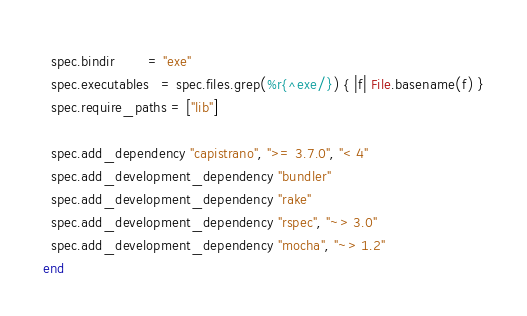<code> <loc_0><loc_0><loc_500><loc_500><_Ruby_>  spec.bindir        = "exe"
  spec.executables   = spec.files.grep(%r{^exe/}) { |f| File.basename(f) }
  spec.require_paths = ["lib"]

  spec.add_dependency "capistrano", ">= 3.7.0", "< 4"
  spec.add_development_dependency "bundler"
  spec.add_development_dependency "rake"
  spec.add_development_dependency "rspec", "~> 3.0"
  spec.add_development_dependency "mocha", "~> 1.2"
end
</code> 